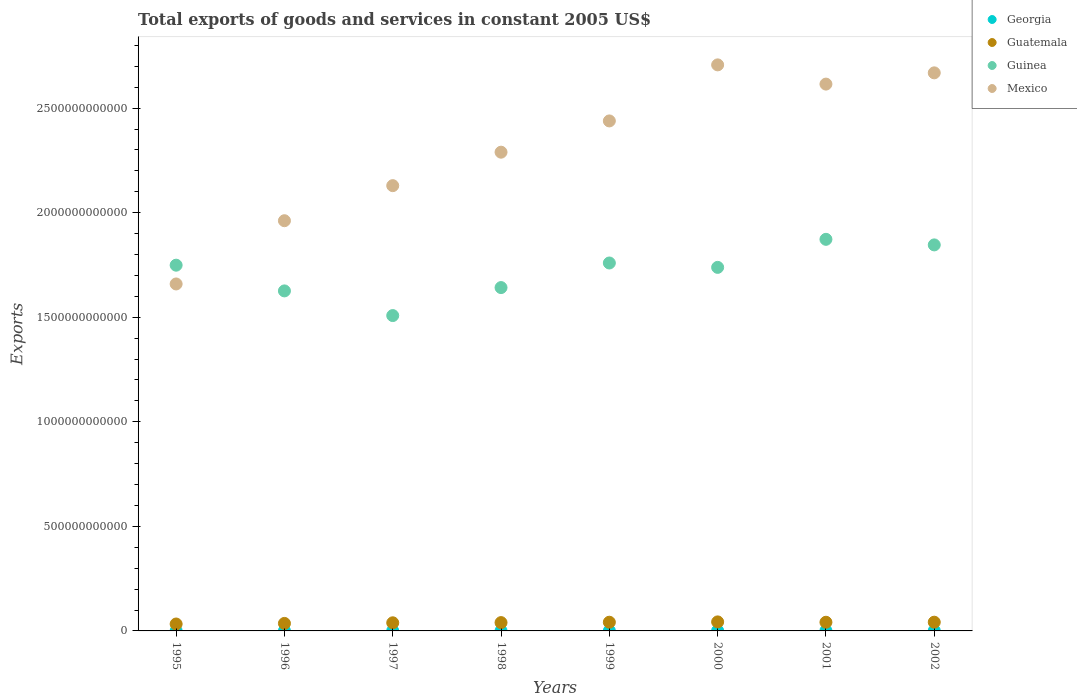How many different coloured dotlines are there?
Provide a short and direct response. 4. What is the total exports of goods and services in Georgia in 1999?
Provide a succinct answer. 8.64e+08. Across all years, what is the maximum total exports of goods and services in Guatemala?
Provide a short and direct response. 4.32e+1. Across all years, what is the minimum total exports of goods and services in Mexico?
Your response must be concise. 1.66e+12. In which year was the total exports of goods and services in Mexico minimum?
Your answer should be very brief. 1995. What is the total total exports of goods and services in Mexico in the graph?
Give a very brief answer. 1.85e+13. What is the difference between the total exports of goods and services in Guatemala in 1995 and that in 2001?
Give a very brief answer. -8.41e+09. What is the difference between the total exports of goods and services in Mexico in 1997 and the total exports of goods and services in Georgia in 1996?
Your answer should be compact. 2.13e+12. What is the average total exports of goods and services in Georgia per year?
Give a very brief answer. 8.73e+08. In the year 2002, what is the difference between the total exports of goods and services in Guatemala and total exports of goods and services in Mexico?
Your response must be concise. -2.63e+12. What is the ratio of the total exports of goods and services in Georgia in 1997 to that in 2000?
Make the answer very short. 0.63. Is the total exports of goods and services in Guatemala in 1997 less than that in 1999?
Your answer should be very brief. Yes. Is the difference between the total exports of goods and services in Guatemala in 1997 and 2001 greater than the difference between the total exports of goods and services in Mexico in 1997 and 2001?
Offer a very short reply. Yes. What is the difference between the highest and the second highest total exports of goods and services in Georgia?
Your answer should be very brief. 3.08e+08. What is the difference between the highest and the lowest total exports of goods and services in Mexico?
Ensure brevity in your answer.  1.05e+12. Is the sum of the total exports of goods and services in Guinea in 1996 and 2000 greater than the maximum total exports of goods and services in Georgia across all years?
Keep it short and to the point. Yes. Is it the case that in every year, the sum of the total exports of goods and services in Guatemala and total exports of goods and services in Georgia  is greater than the sum of total exports of goods and services in Mexico and total exports of goods and services in Guinea?
Keep it short and to the point. No. Is it the case that in every year, the sum of the total exports of goods and services in Guinea and total exports of goods and services in Guatemala  is greater than the total exports of goods and services in Georgia?
Ensure brevity in your answer.  Yes. Does the total exports of goods and services in Georgia monotonically increase over the years?
Provide a succinct answer. Yes. Is the total exports of goods and services in Guinea strictly greater than the total exports of goods and services in Mexico over the years?
Offer a very short reply. No. How many years are there in the graph?
Provide a succinct answer. 8. What is the difference between two consecutive major ticks on the Y-axis?
Ensure brevity in your answer.  5.00e+11. Does the graph contain grids?
Provide a short and direct response. No. How many legend labels are there?
Keep it short and to the point. 4. What is the title of the graph?
Make the answer very short. Total exports of goods and services in constant 2005 US$. What is the label or title of the Y-axis?
Your answer should be very brief. Exports. What is the Exports in Georgia in 1995?
Your answer should be very brief. 4.73e+08. What is the Exports in Guatemala in 1995?
Your answer should be very brief. 3.31e+1. What is the Exports of Guinea in 1995?
Keep it short and to the point. 1.75e+12. What is the Exports of Mexico in 1995?
Make the answer very short. 1.66e+12. What is the Exports of Georgia in 1996?
Offer a terse response. 5.16e+08. What is the Exports of Guatemala in 1996?
Give a very brief answer. 3.59e+1. What is the Exports in Guinea in 1996?
Make the answer very short. 1.63e+12. What is the Exports of Mexico in 1996?
Your response must be concise. 1.96e+12. What is the Exports of Georgia in 1997?
Ensure brevity in your answer.  6.67e+08. What is the Exports of Guatemala in 1997?
Keep it short and to the point. 3.88e+1. What is the Exports of Guinea in 1997?
Offer a terse response. 1.51e+12. What is the Exports of Mexico in 1997?
Offer a very short reply. 2.13e+12. What is the Exports of Georgia in 1998?
Your answer should be compact. 7.26e+08. What is the Exports of Guatemala in 1998?
Make the answer very short. 3.98e+1. What is the Exports of Guinea in 1998?
Your answer should be compact. 1.64e+12. What is the Exports of Mexico in 1998?
Make the answer very short. 2.29e+12. What is the Exports of Georgia in 1999?
Ensure brevity in your answer.  8.64e+08. What is the Exports of Guatemala in 1999?
Offer a terse response. 4.16e+1. What is the Exports in Guinea in 1999?
Give a very brief answer. 1.76e+12. What is the Exports in Mexico in 1999?
Keep it short and to the point. 2.44e+12. What is the Exports in Georgia in 2000?
Make the answer very short. 1.06e+09. What is the Exports of Guatemala in 2000?
Make the answer very short. 4.32e+1. What is the Exports of Guinea in 2000?
Offer a very short reply. 1.74e+12. What is the Exports of Mexico in 2000?
Your answer should be compact. 2.71e+12. What is the Exports of Georgia in 2001?
Make the answer very short. 1.18e+09. What is the Exports in Guatemala in 2001?
Offer a very short reply. 4.15e+1. What is the Exports of Guinea in 2001?
Provide a short and direct response. 1.87e+12. What is the Exports of Mexico in 2001?
Keep it short and to the point. 2.61e+12. What is the Exports of Georgia in 2002?
Make the answer very short. 1.49e+09. What is the Exports in Guatemala in 2002?
Provide a succinct answer. 4.18e+1. What is the Exports of Guinea in 2002?
Offer a terse response. 1.85e+12. What is the Exports in Mexico in 2002?
Give a very brief answer. 2.67e+12. Across all years, what is the maximum Exports in Georgia?
Offer a terse response. 1.49e+09. Across all years, what is the maximum Exports in Guatemala?
Give a very brief answer. 4.32e+1. Across all years, what is the maximum Exports of Guinea?
Ensure brevity in your answer.  1.87e+12. Across all years, what is the maximum Exports in Mexico?
Ensure brevity in your answer.  2.71e+12. Across all years, what is the minimum Exports in Georgia?
Offer a very short reply. 4.73e+08. Across all years, what is the minimum Exports in Guatemala?
Give a very brief answer. 3.31e+1. Across all years, what is the minimum Exports in Guinea?
Make the answer very short. 1.51e+12. Across all years, what is the minimum Exports of Mexico?
Provide a succinct answer. 1.66e+12. What is the total Exports of Georgia in the graph?
Your answer should be compact. 6.98e+09. What is the total Exports of Guatemala in the graph?
Ensure brevity in your answer.  3.16e+11. What is the total Exports of Guinea in the graph?
Keep it short and to the point. 1.37e+13. What is the total Exports in Mexico in the graph?
Provide a succinct answer. 1.85e+13. What is the difference between the Exports in Georgia in 1995 and that in 1996?
Offer a very short reply. -4.24e+07. What is the difference between the Exports in Guatemala in 1995 and that in 1996?
Your response must be concise. -2.87e+09. What is the difference between the Exports in Guinea in 1995 and that in 1996?
Your answer should be very brief. 1.23e+11. What is the difference between the Exports of Mexico in 1995 and that in 1996?
Offer a very short reply. -3.02e+11. What is the difference between the Exports in Georgia in 1995 and that in 1997?
Your answer should be very brief. -1.94e+08. What is the difference between the Exports in Guatemala in 1995 and that in 1997?
Offer a very short reply. -5.78e+09. What is the difference between the Exports of Guinea in 1995 and that in 1997?
Give a very brief answer. 2.41e+11. What is the difference between the Exports in Mexico in 1995 and that in 1997?
Give a very brief answer. -4.70e+11. What is the difference between the Exports of Georgia in 1995 and that in 1998?
Give a very brief answer. -2.52e+08. What is the difference between the Exports of Guatemala in 1995 and that in 1998?
Provide a succinct answer. -6.71e+09. What is the difference between the Exports of Guinea in 1995 and that in 1998?
Keep it short and to the point. 1.07e+11. What is the difference between the Exports of Mexico in 1995 and that in 1998?
Provide a short and direct response. -6.30e+11. What is the difference between the Exports in Georgia in 1995 and that in 1999?
Provide a succinct answer. -3.91e+08. What is the difference between the Exports of Guatemala in 1995 and that in 1999?
Your answer should be very brief. -8.54e+09. What is the difference between the Exports in Guinea in 1995 and that in 1999?
Offer a terse response. -1.05e+1. What is the difference between the Exports in Mexico in 1995 and that in 1999?
Your response must be concise. -7.80e+11. What is the difference between the Exports in Georgia in 1995 and that in 2000?
Provide a succinct answer. -5.89e+08. What is the difference between the Exports of Guatemala in 1995 and that in 2000?
Your response must be concise. -1.01e+1. What is the difference between the Exports in Guinea in 1995 and that in 2000?
Ensure brevity in your answer.  1.05e+1. What is the difference between the Exports in Mexico in 1995 and that in 2000?
Make the answer very short. -1.05e+12. What is the difference between the Exports in Georgia in 1995 and that in 2001?
Provide a short and direct response. -7.11e+08. What is the difference between the Exports in Guatemala in 1995 and that in 2001?
Give a very brief answer. -8.41e+09. What is the difference between the Exports of Guinea in 1995 and that in 2001?
Your response must be concise. -1.24e+11. What is the difference between the Exports in Mexico in 1995 and that in 2001?
Your answer should be compact. -9.56e+11. What is the difference between the Exports of Georgia in 1995 and that in 2002?
Your answer should be very brief. -1.02e+09. What is the difference between the Exports of Guatemala in 1995 and that in 2002?
Your response must be concise. -8.70e+09. What is the difference between the Exports in Guinea in 1995 and that in 2002?
Provide a short and direct response. -9.69e+1. What is the difference between the Exports of Mexico in 1995 and that in 2002?
Provide a succinct answer. -1.01e+12. What is the difference between the Exports in Georgia in 1996 and that in 1997?
Make the answer very short. -1.52e+08. What is the difference between the Exports in Guatemala in 1996 and that in 1997?
Provide a succinct answer. -2.91e+09. What is the difference between the Exports of Guinea in 1996 and that in 1997?
Make the answer very short. 1.18e+11. What is the difference between the Exports of Mexico in 1996 and that in 1997?
Your answer should be compact. -1.68e+11. What is the difference between the Exports in Georgia in 1996 and that in 1998?
Your answer should be compact. -2.10e+08. What is the difference between the Exports in Guatemala in 1996 and that in 1998?
Offer a terse response. -3.84e+09. What is the difference between the Exports in Guinea in 1996 and that in 1998?
Your response must be concise. -1.59e+1. What is the difference between the Exports in Mexico in 1996 and that in 1998?
Your answer should be very brief. -3.28e+11. What is the difference between the Exports of Georgia in 1996 and that in 1999?
Your answer should be compact. -3.49e+08. What is the difference between the Exports of Guatemala in 1996 and that in 1999?
Your answer should be compact. -5.67e+09. What is the difference between the Exports in Guinea in 1996 and that in 1999?
Your answer should be compact. -1.33e+11. What is the difference between the Exports of Mexico in 1996 and that in 1999?
Ensure brevity in your answer.  -4.77e+11. What is the difference between the Exports of Georgia in 1996 and that in 2000?
Your answer should be very brief. -5.46e+08. What is the difference between the Exports of Guatemala in 1996 and that in 2000?
Offer a very short reply. -7.26e+09. What is the difference between the Exports of Guinea in 1996 and that in 2000?
Offer a terse response. -1.13e+11. What is the difference between the Exports of Mexico in 1996 and that in 2000?
Offer a very short reply. -7.45e+11. What is the difference between the Exports in Georgia in 1996 and that in 2001?
Offer a very short reply. -6.68e+08. What is the difference between the Exports of Guatemala in 1996 and that in 2001?
Ensure brevity in your answer.  -5.54e+09. What is the difference between the Exports in Guinea in 1996 and that in 2001?
Provide a short and direct response. -2.47e+11. What is the difference between the Exports in Mexico in 1996 and that in 2001?
Keep it short and to the point. -6.53e+11. What is the difference between the Exports of Georgia in 1996 and that in 2002?
Keep it short and to the point. -9.77e+08. What is the difference between the Exports of Guatemala in 1996 and that in 2002?
Provide a succinct answer. -5.83e+09. What is the difference between the Exports of Guinea in 1996 and that in 2002?
Give a very brief answer. -2.20e+11. What is the difference between the Exports in Mexico in 1996 and that in 2002?
Give a very brief answer. -7.07e+11. What is the difference between the Exports in Georgia in 1997 and that in 1998?
Offer a very short reply. -5.81e+07. What is the difference between the Exports in Guatemala in 1997 and that in 1998?
Your answer should be very brief. -9.30e+08. What is the difference between the Exports of Guinea in 1997 and that in 1998?
Provide a succinct answer. -1.34e+11. What is the difference between the Exports in Mexico in 1997 and that in 1998?
Provide a succinct answer. -1.60e+11. What is the difference between the Exports of Georgia in 1997 and that in 1999?
Provide a succinct answer. -1.97e+08. What is the difference between the Exports of Guatemala in 1997 and that in 1999?
Provide a short and direct response. -2.76e+09. What is the difference between the Exports of Guinea in 1997 and that in 1999?
Ensure brevity in your answer.  -2.51e+11. What is the difference between the Exports of Mexico in 1997 and that in 1999?
Your answer should be very brief. -3.09e+11. What is the difference between the Exports in Georgia in 1997 and that in 2000?
Offer a very short reply. -3.94e+08. What is the difference between the Exports of Guatemala in 1997 and that in 2000?
Keep it short and to the point. -4.35e+09. What is the difference between the Exports in Guinea in 1997 and that in 2000?
Provide a short and direct response. -2.31e+11. What is the difference between the Exports in Mexico in 1997 and that in 2000?
Provide a succinct answer. -5.78e+11. What is the difference between the Exports in Georgia in 1997 and that in 2001?
Give a very brief answer. -5.17e+08. What is the difference between the Exports in Guatemala in 1997 and that in 2001?
Your response must be concise. -2.63e+09. What is the difference between the Exports of Guinea in 1997 and that in 2001?
Make the answer very short. -3.65e+11. What is the difference between the Exports in Mexico in 1997 and that in 2001?
Keep it short and to the point. -4.86e+11. What is the difference between the Exports of Georgia in 1997 and that in 2002?
Offer a very short reply. -8.25e+08. What is the difference between the Exports in Guatemala in 1997 and that in 2002?
Ensure brevity in your answer.  -2.92e+09. What is the difference between the Exports of Guinea in 1997 and that in 2002?
Offer a very short reply. -3.38e+11. What is the difference between the Exports of Mexico in 1997 and that in 2002?
Make the answer very short. -5.39e+11. What is the difference between the Exports in Georgia in 1998 and that in 1999?
Provide a succinct answer. -1.39e+08. What is the difference between the Exports of Guatemala in 1998 and that in 1999?
Keep it short and to the point. -1.83e+09. What is the difference between the Exports in Guinea in 1998 and that in 1999?
Provide a short and direct response. -1.18e+11. What is the difference between the Exports in Mexico in 1998 and that in 1999?
Provide a short and direct response. -1.49e+11. What is the difference between the Exports in Georgia in 1998 and that in 2000?
Offer a terse response. -3.36e+08. What is the difference between the Exports of Guatemala in 1998 and that in 2000?
Provide a short and direct response. -3.42e+09. What is the difference between the Exports in Guinea in 1998 and that in 2000?
Ensure brevity in your answer.  -9.66e+1. What is the difference between the Exports in Mexico in 1998 and that in 2000?
Offer a very short reply. -4.18e+11. What is the difference between the Exports of Georgia in 1998 and that in 2001?
Offer a very short reply. -4.58e+08. What is the difference between the Exports of Guatemala in 1998 and that in 2001?
Give a very brief answer. -1.70e+09. What is the difference between the Exports in Guinea in 1998 and that in 2001?
Keep it short and to the point. -2.31e+11. What is the difference between the Exports in Mexico in 1998 and that in 2001?
Provide a succinct answer. -3.26e+11. What is the difference between the Exports of Georgia in 1998 and that in 2002?
Your answer should be very brief. -7.67e+08. What is the difference between the Exports of Guatemala in 1998 and that in 2002?
Your answer should be very brief. -1.99e+09. What is the difference between the Exports of Guinea in 1998 and that in 2002?
Provide a short and direct response. -2.04e+11. What is the difference between the Exports in Mexico in 1998 and that in 2002?
Provide a short and direct response. -3.79e+11. What is the difference between the Exports of Georgia in 1999 and that in 2000?
Offer a terse response. -1.98e+08. What is the difference between the Exports in Guatemala in 1999 and that in 2000?
Give a very brief answer. -1.59e+09. What is the difference between the Exports in Guinea in 1999 and that in 2000?
Make the answer very short. 2.10e+1. What is the difference between the Exports in Mexico in 1999 and that in 2000?
Provide a succinct answer. -2.68e+11. What is the difference between the Exports of Georgia in 1999 and that in 2001?
Ensure brevity in your answer.  -3.20e+08. What is the difference between the Exports in Guatemala in 1999 and that in 2001?
Ensure brevity in your answer.  1.35e+08. What is the difference between the Exports in Guinea in 1999 and that in 2001?
Offer a very short reply. -1.13e+11. What is the difference between the Exports of Mexico in 1999 and that in 2001?
Make the answer very short. -1.76e+11. What is the difference between the Exports of Georgia in 1999 and that in 2002?
Keep it short and to the point. -6.28e+08. What is the difference between the Exports of Guatemala in 1999 and that in 2002?
Make the answer very short. -1.59e+08. What is the difference between the Exports of Guinea in 1999 and that in 2002?
Your answer should be very brief. -8.65e+1. What is the difference between the Exports in Mexico in 1999 and that in 2002?
Offer a terse response. -2.30e+11. What is the difference between the Exports of Georgia in 2000 and that in 2001?
Keep it short and to the point. -1.22e+08. What is the difference between the Exports of Guatemala in 2000 and that in 2001?
Make the answer very short. 1.72e+09. What is the difference between the Exports in Guinea in 2000 and that in 2001?
Your answer should be very brief. -1.34e+11. What is the difference between the Exports of Mexico in 2000 and that in 2001?
Offer a terse response. 9.19e+1. What is the difference between the Exports in Georgia in 2000 and that in 2002?
Provide a succinct answer. -4.30e+08. What is the difference between the Exports of Guatemala in 2000 and that in 2002?
Give a very brief answer. 1.43e+09. What is the difference between the Exports in Guinea in 2000 and that in 2002?
Provide a succinct answer. -1.07e+11. What is the difference between the Exports of Mexico in 2000 and that in 2002?
Your answer should be compact. 3.81e+1. What is the difference between the Exports of Georgia in 2001 and that in 2002?
Ensure brevity in your answer.  -3.08e+08. What is the difference between the Exports in Guatemala in 2001 and that in 2002?
Your answer should be compact. -2.94e+08. What is the difference between the Exports of Guinea in 2001 and that in 2002?
Provide a succinct answer. 2.67e+1. What is the difference between the Exports of Mexico in 2001 and that in 2002?
Provide a short and direct response. -5.38e+1. What is the difference between the Exports of Georgia in 1995 and the Exports of Guatemala in 1996?
Give a very brief answer. -3.54e+1. What is the difference between the Exports of Georgia in 1995 and the Exports of Guinea in 1996?
Keep it short and to the point. -1.63e+12. What is the difference between the Exports in Georgia in 1995 and the Exports in Mexico in 1996?
Provide a short and direct response. -1.96e+12. What is the difference between the Exports in Guatemala in 1995 and the Exports in Guinea in 1996?
Provide a succinct answer. -1.59e+12. What is the difference between the Exports in Guatemala in 1995 and the Exports in Mexico in 1996?
Provide a succinct answer. -1.93e+12. What is the difference between the Exports in Guinea in 1995 and the Exports in Mexico in 1996?
Your answer should be very brief. -2.13e+11. What is the difference between the Exports of Georgia in 1995 and the Exports of Guatemala in 1997?
Provide a short and direct response. -3.84e+1. What is the difference between the Exports in Georgia in 1995 and the Exports in Guinea in 1997?
Offer a very short reply. -1.51e+12. What is the difference between the Exports of Georgia in 1995 and the Exports of Mexico in 1997?
Your answer should be compact. -2.13e+12. What is the difference between the Exports in Guatemala in 1995 and the Exports in Guinea in 1997?
Make the answer very short. -1.47e+12. What is the difference between the Exports in Guatemala in 1995 and the Exports in Mexico in 1997?
Offer a very short reply. -2.10e+12. What is the difference between the Exports in Guinea in 1995 and the Exports in Mexico in 1997?
Your response must be concise. -3.80e+11. What is the difference between the Exports of Georgia in 1995 and the Exports of Guatemala in 1998?
Your response must be concise. -3.93e+1. What is the difference between the Exports in Georgia in 1995 and the Exports in Guinea in 1998?
Your answer should be compact. -1.64e+12. What is the difference between the Exports in Georgia in 1995 and the Exports in Mexico in 1998?
Your answer should be compact. -2.29e+12. What is the difference between the Exports in Guatemala in 1995 and the Exports in Guinea in 1998?
Your answer should be very brief. -1.61e+12. What is the difference between the Exports of Guatemala in 1995 and the Exports of Mexico in 1998?
Provide a succinct answer. -2.26e+12. What is the difference between the Exports in Guinea in 1995 and the Exports in Mexico in 1998?
Provide a short and direct response. -5.40e+11. What is the difference between the Exports of Georgia in 1995 and the Exports of Guatemala in 1999?
Offer a very short reply. -4.11e+1. What is the difference between the Exports in Georgia in 1995 and the Exports in Guinea in 1999?
Your answer should be very brief. -1.76e+12. What is the difference between the Exports in Georgia in 1995 and the Exports in Mexico in 1999?
Your answer should be compact. -2.44e+12. What is the difference between the Exports of Guatemala in 1995 and the Exports of Guinea in 1999?
Make the answer very short. -1.73e+12. What is the difference between the Exports in Guatemala in 1995 and the Exports in Mexico in 1999?
Give a very brief answer. -2.41e+12. What is the difference between the Exports in Guinea in 1995 and the Exports in Mexico in 1999?
Provide a succinct answer. -6.90e+11. What is the difference between the Exports of Georgia in 1995 and the Exports of Guatemala in 2000?
Your response must be concise. -4.27e+1. What is the difference between the Exports of Georgia in 1995 and the Exports of Guinea in 2000?
Provide a short and direct response. -1.74e+12. What is the difference between the Exports in Georgia in 1995 and the Exports in Mexico in 2000?
Offer a terse response. -2.71e+12. What is the difference between the Exports of Guatemala in 1995 and the Exports of Guinea in 2000?
Provide a short and direct response. -1.71e+12. What is the difference between the Exports in Guatemala in 1995 and the Exports in Mexico in 2000?
Ensure brevity in your answer.  -2.67e+12. What is the difference between the Exports of Guinea in 1995 and the Exports of Mexico in 2000?
Provide a short and direct response. -9.58e+11. What is the difference between the Exports of Georgia in 1995 and the Exports of Guatemala in 2001?
Your answer should be very brief. -4.10e+1. What is the difference between the Exports in Georgia in 1995 and the Exports in Guinea in 2001?
Ensure brevity in your answer.  -1.87e+12. What is the difference between the Exports of Georgia in 1995 and the Exports of Mexico in 2001?
Offer a terse response. -2.61e+12. What is the difference between the Exports in Guatemala in 1995 and the Exports in Guinea in 2001?
Your response must be concise. -1.84e+12. What is the difference between the Exports in Guatemala in 1995 and the Exports in Mexico in 2001?
Ensure brevity in your answer.  -2.58e+12. What is the difference between the Exports of Guinea in 1995 and the Exports of Mexico in 2001?
Your response must be concise. -8.66e+11. What is the difference between the Exports of Georgia in 1995 and the Exports of Guatemala in 2002?
Provide a succinct answer. -4.13e+1. What is the difference between the Exports of Georgia in 1995 and the Exports of Guinea in 2002?
Ensure brevity in your answer.  -1.85e+12. What is the difference between the Exports in Georgia in 1995 and the Exports in Mexico in 2002?
Make the answer very short. -2.67e+12. What is the difference between the Exports of Guatemala in 1995 and the Exports of Guinea in 2002?
Provide a succinct answer. -1.81e+12. What is the difference between the Exports of Guatemala in 1995 and the Exports of Mexico in 2002?
Your answer should be compact. -2.64e+12. What is the difference between the Exports of Guinea in 1995 and the Exports of Mexico in 2002?
Ensure brevity in your answer.  -9.20e+11. What is the difference between the Exports in Georgia in 1996 and the Exports in Guatemala in 1997?
Keep it short and to the point. -3.83e+1. What is the difference between the Exports of Georgia in 1996 and the Exports of Guinea in 1997?
Give a very brief answer. -1.51e+12. What is the difference between the Exports of Georgia in 1996 and the Exports of Mexico in 1997?
Provide a succinct answer. -2.13e+12. What is the difference between the Exports of Guatemala in 1996 and the Exports of Guinea in 1997?
Offer a terse response. -1.47e+12. What is the difference between the Exports of Guatemala in 1996 and the Exports of Mexico in 1997?
Keep it short and to the point. -2.09e+12. What is the difference between the Exports of Guinea in 1996 and the Exports of Mexico in 1997?
Ensure brevity in your answer.  -5.03e+11. What is the difference between the Exports in Georgia in 1996 and the Exports in Guatemala in 1998?
Your answer should be compact. -3.92e+1. What is the difference between the Exports of Georgia in 1996 and the Exports of Guinea in 1998?
Make the answer very short. -1.64e+12. What is the difference between the Exports in Georgia in 1996 and the Exports in Mexico in 1998?
Offer a terse response. -2.29e+12. What is the difference between the Exports in Guatemala in 1996 and the Exports in Guinea in 1998?
Make the answer very short. -1.61e+12. What is the difference between the Exports of Guatemala in 1996 and the Exports of Mexico in 1998?
Provide a short and direct response. -2.25e+12. What is the difference between the Exports of Guinea in 1996 and the Exports of Mexico in 1998?
Offer a terse response. -6.63e+11. What is the difference between the Exports of Georgia in 1996 and the Exports of Guatemala in 1999?
Offer a terse response. -4.11e+1. What is the difference between the Exports of Georgia in 1996 and the Exports of Guinea in 1999?
Offer a very short reply. -1.76e+12. What is the difference between the Exports of Georgia in 1996 and the Exports of Mexico in 1999?
Offer a terse response. -2.44e+12. What is the difference between the Exports of Guatemala in 1996 and the Exports of Guinea in 1999?
Ensure brevity in your answer.  -1.72e+12. What is the difference between the Exports of Guatemala in 1996 and the Exports of Mexico in 1999?
Your answer should be compact. -2.40e+12. What is the difference between the Exports in Guinea in 1996 and the Exports in Mexico in 1999?
Provide a succinct answer. -8.13e+11. What is the difference between the Exports in Georgia in 1996 and the Exports in Guatemala in 2000?
Your response must be concise. -4.27e+1. What is the difference between the Exports in Georgia in 1996 and the Exports in Guinea in 2000?
Provide a short and direct response. -1.74e+12. What is the difference between the Exports in Georgia in 1996 and the Exports in Mexico in 2000?
Offer a very short reply. -2.71e+12. What is the difference between the Exports of Guatemala in 1996 and the Exports of Guinea in 2000?
Your answer should be very brief. -1.70e+12. What is the difference between the Exports in Guatemala in 1996 and the Exports in Mexico in 2000?
Provide a succinct answer. -2.67e+12. What is the difference between the Exports of Guinea in 1996 and the Exports of Mexico in 2000?
Provide a short and direct response. -1.08e+12. What is the difference between the Exports of Georgia in 1996 and the Exports of Guatemala in 2001?
Your response must be concise. -4.09e+1. What is the difference between the Exports in Georgia in 1996 and the Exports in Guinea in 2001?
Give a very brief answer. -1.87e+12. What is the difference between the Exports of Georgia in 1996 and the Exports of Mexico in 2001?
Make the answer very short. -2.61e+12. What is the difference between the Exports in Guatemala in 1996 and the Exports in Guinea in 2001?
Offer a terse response. -1.84e+12. What is the difference between the Exports of Guatemala in 1996 and the Exports of Mexico in 2001?
Your response must be concise. -2.58e+12. What is the difference between the Exports in Guinea in 1996 and the Exports in Mexico in 2001?
Keep it short and to the point. -9.89e+11. What is the difference between the Exports of Georgia in 1996 and the Exports of Guatemala in 2002?
Offer a very short reply. -4.12e+1. What is the difference between the Exports of Georgia in 1996 and the Exports of Guinea in 2002?
Keep it short and to the point. -1.85e+12. What is the difference between the Exports of Georgia in 1996 and the Exports of Mexico in 2002?
Your answer should be compact. -2.67e+12. What is the difference between the Exports in Guatemala in 1996 and the Exports in Guinea in 2002?
Offer a terse response. -1.81e+12. What is the difference between the Exports of Guatemala in 1996 and the Exports of Mexico in 2002?
Keep it short and to the point. -2.63e+12. What is the difference between the Exports of Guinea in 1996 and the Exports of Mexico in 2002?
Make the answer very short. -1.04e+12. What is the difference between the Exports of Georgia in 1997 and the Exports of Guatemala in 1998?
Your answer should be very brief. -3.91e+1. What is the difference between the Exports of Georgia in 1997 and the Exports of Guinea in 1998?
Your answer should be very brief. -1.64e+12. What is the difference between the Exports in Georgia in 1997 and the Exports in Mexico in 1998?
Give a very brief answer. -2.29e+12. What is the difference between the Exports in Guatemala in 1997 and the Exports in Guinea in 1998?
Provide a short and direct response. -1.60e+12. What is the difference between the Exports of Guatemala in 1997 and the Exports of Mexico in 1998?
Ensure brevity in your answer.  -2.25e+12. What is the difference between the Exports in Guinea in 1997 and the Exports in Mexico in 1998?
Provide a short and direct response. -7.81e+11. What is the difference between the Exports of Georgia in 1997 and the Exports of Guatemala in 1999?
Your response must be concise. -4.09e+1. What is the difference between the Exports in Georgia in 1997 and the Exports in Guinea in 1999?
Offer a very short reply. -1.76e+12. What is the difference between the Exports in Georgia in 1997 and the Exports in Mexico in 1999?
Keep it short and to the point. -2.44e+12. What is the difference between the Exports of Guatemala in 1997 and the Exports of Guinea in 1999?
Give a very brief answer. -1.72e+12. What is the difference between the Exports in Guatemala in 1997 and the Exports in Mexico in 1999?
Offer a very short reply. -2.40e+12. What is the difference between the Exports in Guinea in 1997 and the Exports in Mexico in 1999?
Offer a terse response. -9.31e+11. What is the difference between the Exports in Georgia in 1997 and the Exports in Guatemala in 2000?
Your response must be concise. -4.25e+1. What is the difference between the Exports in Georgia in 1997 and the Exports in Guinea in 2000?
Provide a succinct answer. -1.74e+12. What is the difference between the Exports in Georgia in 1997 and the Exports in Mexico in 2000?
Give a very brief answer. -2.71e+12. What is the difference between the Exports in Guatemala in 1997 and the Exports in Guinea in 2000?
Your answer should be very brief. -1.70e+12. What is the difference between the Exports of Guatemala in 1997 and the Exports of Mexico in 2000?
Provide a short and direct response. -2.67e+12. What is the difference between the Exports in Guinea in 1997 and the Exports in Mexico in 2000?
Make the answer very short. -1.20e+12. What is the difference between the Exports of Georgia in 1997 and the Exports of Guatemala in 2001?
Ensure brevity in your answer.  -4.08e+1. What is the difference between the Exports in Georgia in 1997 and the Exports in Guinea in 2001?
Make the answer very short. -1.87e+12. What is the difference between the Exports in Georgia in 1997 and the Exports in Mexico in 2001?
Ensure brevity in your answer.  -2.61e+12. What is the difference between the Exports in Guatemala in 1997 and the Exports in Guinea in 2001?
Your response must be concise. -1.83e+12. What is the difference between the Exports in Guatemala in 1997 and the Exports in Mexico in 2001?
Your answer should be very brief. -2.58e+12. What is the difference between the Exports of Guinea in 1997 and the Exports of Mexico in 2001?
Provide a short and direct response. -1.11e+12. What is the difference between the Exports in Georgia in 1997 and the Exports in Guatemala in 2002?
Ensure brevity in your answer.  -4.11e+1. What is the difference between the Exports of Georgia in 1997 and the Exports of Guinea in 2002?
Offer a very short reply. -1.85e+12. What is the difference between the Exports in Georgia in 1997 and the Exports in Mexico in 2002?
Provide a short and direct response. -2.67e+12. What is the difference between the Exports of Guatemala in 1997 and the Exports of Guinea in 2002?
Keep it short and to the point. -1.81e+12. What is the difference between the Exports of Guatemala in 1997 and the Exports of Mexico in 2002?
Your answer should be compact. -2.63e+12. What is the difference between the Exports of Guinea in 1997 and the Exports of Mexico in 2002?
Provide a short and direct response. -1.16e+12. What is the difference between the Exports of Georgia in 1998 and the Exports of Guatemala in 1999?
Ensure brevity in your answer.  -4.09e+1. What is the difference between the Exports of Georgia in 1998 and the Exports of Guinea in 1999?
Your response must be concise. -1.76e+12. What is the difference between the Exports in Georgia in 1998 and the Exports in Mexico in 1999?
Provide a succinct answer. -2.44e+12. What is the difference between the Exports of Guatemala in 1998 and the Exports of Guinea in 1999?
Your answer should be compact. -1.72e+12. What is the difference between the Exports of Guatemala in 1998 and the Exports of Mexico in 1999?
Offer a terse response. -2.40e+12. What is the difference between the Exports in Guinea in 1998 and the Exports in Mexico in 1999?
Give a very brief answer. -7.97e+11. What is the difference between the Exports of Georgia in 1998 and the Exports of Guatemala in 2000?
Provide a short and direct response. -4.25e+1. What is the difference between the Exports of Georgia in 1998 and the Exports of Guinea in 2000?
Your answer should be compact. -1.74e+12. What is the difference between the Exports in Georgia in 1998 and the Exports in Mexico in 2000?
Your answer should be compact. -2.71e+12. What is the difference between the Exports in Guatemala in 1998 and the Exports in Guinea in 2000?
Your response must be concise. -1.70e+12. What is the difference between the Exports of Guatemala in 1998 and the Exports of Mexico in 2000?
Provide a succinct answer. -2.67e+12. What is the difference between the Exports of Guinea in 1998 and the Exports of Mexico in 2000?
Provide a succinct answer. -1.06e+12. What is the difference between the Exports in Georgia in 1998 and the Exports in Guatemala in 2001?
Your response must be concise. -4.07e+1. What is the difference between the Exports of Georgia in 1998 and the Exports of Guinea in 2001?
Offer a very short reply. -1.87e+12. What is the difference between the Exports in Georgia in 1998 and the Exports in Mexico in 2001?
Your response must be concise. -2.61e+12. What is the difference between the Exports in Guatemala in 1998 and the Exports in Guinea in 2001?
Offer a very short reply. -1.83e+12. What is the difference between the Exports in Guatemala in 1998 and the Exports in Mexico in 2001?
Your answer should be very brief. -2.58e+12. What is the difference between the Exports in Guinea in 1998 and the Exports in Mexico in 2001?
Keep it short and to the point. -9.73e+11. What is the difference between the Exports of Georgia in 1998 and the Exports of Guatemala in 2002?
Make the answer very short. -4.10e+1. What is the difference between the Exports of Georgia in 1998 and the Exports of Guinea in 2002?
Ensure brevity in your answer.  -1.85e+12. What is the difference between the Exports of Georgia in 1998 and the Exports of Mexico in 2002?
Give a very brief answer. -2.67e+12. What is the difference between the Exports in Guatemala in 1998 and the Exports in Guinea in 2002?
Make the answer very short. -1.81e+12. What is the difference between the Exports of Guatemala in 1998 and the Exports of Mexico in 2002?
Offer a terse response. -2.63e+12. What is the difference between the Exports in Guinea in 1998 and the Exports in Mexico in 2002?
Your response must be concise. -1.03e+12. What is the difference between the Exports of Georgia in 1999 and the Exports of Guatemala in 2000?
Keep it short and to the point. -4.23e+1. What is the difference between the Exports in Georgia in 1999 and the Exports in Guinea in 2000?
Your response must be concise. -1.74e+12. What is the difference between the Exports of Georgia in 1999 and the Exports of Mexico in 2000?
Your answer should be compact. -2.71e+12. What is the difference between the Exports in Guatemala in 1999 and the Exports in Guinea in 2000?
Make the answer very short. -1.70e+12. What is the difference between the Exports in Guatemala in 1999 and the Exports in Mexico in 2000?
Ensure brevity in your answer.  -2.67e+12. What is the difference between the Exports in Guinea in 1999 and the Exports in Mexico in 2000?
Your response must be concise. -9.47e+11. What is the difference between the Exports in Georgia in 1999 and the Exports in Guatemala in 2001?
Keep it short and to the point. -4.06e+1. What is the difference between the Exports in Georgia in 1999 and the Exports in Guinea in 2001?
Make the answer very short. -1.87e+12. What is the difference between the Exports in Georgia in 1999 and the Exports in Mexico in 2001?
Ensure brevity in your answer.  -2.61e+12. What is the difference between the Exports of Guatemala in 1999 and the Exports of Guinea in 2001?
Offer a very short reply. -1.83e+12. What is the difference between the Exports of Guatemala in 1999 and the Exports of Mexico in 2001?
Ensure brevity in your answer.  -2.57e+12. What is the difference between the Exports of Guinea in 1999 and the Exports of Mexico in 2001?
Your answer should be very brief. -8.55e+11. What is the difference between the Exports of Georgia in 1999 and the Exports of Guatemala in 2002?
Your answer should be very brief. -4.09e+1. What is the difference between the Exports of Georgia in 1999 and the Exports of Guinea in 2002?
Offer a terse response. -1.85e+12. What is the difference between the Exports in Georgia in 1999 and the Exports in Mexico in 2002?
Provide a succinct answer. -2.67e+12. What is the difference between the Exports in Guatemala in 1999 and the Exports in Guinea in 2002?
Provide a short and direct response. -1.80e+12. What is the difference between the Exports in Guatemala in 1999 and the Exports in Mexico in 2002?
Offer a very short reply. -2.63e+12. What is the difference between the Exports in Guinea in 1999 and the Exports in Mexico in 2002?
Your answer should be very brief. -9.09e+11. What is the difference between the Exports of Georgia in 2000 and the Exports of Guatemala in 2001?
Keep it short and to the point. -4.04e+1. What is the difference between the Exports of Georgia in 2000 and the Exports of Guinea in 2001?
Your response must be concise. -1.87e+12. What is the difference between the Exports in Georgia in 2000 and the Exports in Mexico in 2001?
Provide a short and direct response. -2.61e+12. What is the difference between the Exports in Guatemala in 2000 and the Exports in Guinea in 2001?
Your response must be concise. -1.83e+12. What is the difference between the Exports in Guatemala in 2000 and the Exports in Mexico in 2001?
Give a very brief answer. -2.57e+12. What is the difference between the Exports of Guinea in 2000 and the Exports of Mexico in 2001?
Keep it short and to the point. -8.76e+11. What is the difference between the Exports of Georgia in 2000 and the Exports of Guatemala in 2002?
Your answer should be compact. -4.07e+1. What is the difference between the Exports of Georgia in 2000 and the Exports of Guinea in 2002?
Give a very brief answer. -1.84e+12. What is the difference between the Exports in Georgia in 2000 and the Exports in Mexico in 2002?
Your answer should be very brief. -2.67e+12. What is the difference between the Exports in Guatemala in 2000 and the Exports in Guinea in 2002?
Your answer should be very brief. -1.80e+12. What is the difference between the Exports in Guatemala in 2000 and the Exports in Mexico in 2002?
Ensure brevity in your answer.  -2.63e+12. What is the difference between the Exports in Guinea in 2000 and the Exports in Mexico in 2002?
Keep it short and to the point. -9.30e+11. What is the difference between the Exports of Georgia in 2001 and the Exports of Guatemala in 2002?
Make the answer very short. -4.06e+1. What is the difference between the Exports of Georgia in 2001 and the Exports of Guinea in 2002?
Provide a short and direct response. -1.84e+12. What is the difference between the Exports of Georgia in 2001 and the Exports of Mexico in 2002?
Provide a succinct answer. -2.67e+12. What is the difference between the Exports of Guatemala in 2001 and the Exports of Guinea in 2002?
Your answer should be compact. -1.80e+12. What is the difference between the Exports of Guatemala in 2001 and the Exports of Mexico in 2002?
Keep it short and to the point. -2.63e+12. What is the difference between the Exports of Guinea in 2001 and the Exports of Mexico in 2002?
Your response must be concise. -7.96e+11. What is the average Exports in Georgia per year?
Offer a very short reply. 8.73e+08. What is the average Exports of Guatemala per year?
Your answer should be very brief. 3.94e+1. What is the average Exports of Guinea per year?
Provide a succinct answer. 1.72e+12. What is the average Exports in Mexico per year?
Make the answer very short. 2.31e+12. In the year 1995, what is the difference between the Exports in Georgia and Exports in Guatemala?
Make the answer very short. -3.26e+1. In the year 1995, what is the difference between the Exports in Georgia and Exports in Guinea?
Your answer should be compact. -1.75e+12. In the year 1995, what is the difference between the Exports in Georgia and Exports in Mexico?
Keep it short and to the point. -1.66e+12. In the year 1995, what is the difference between the Exports of Guatemala and Exports of Guinea?
Your answer should be very brief. -1.72e+12. In the year 1995, what is the difference between the Exports of Guatemala and Exports of Mexico?
Offer a terse response. -1.63e+12. In the year 1995, what is the difference between the Exports in Guinea and Exports in Mexico?
Your answer should be very brief. 8.98e+1. In the year 1996, what is the difference between the Exports in Georgia and Exports in Guatemala?
Offer a terse response. -3.54e+1. In the year 1996, what is the difference between the Exports of Georgia and Exports of Guinea?
Give a very brief answer. -1.63e+12. In the year 1996, what is the difference between the Exports in Georgia and Exports in Mexico?
Ensure brevity in your answer.  -1.96e+12. In the year 1996, what is the difference between the Exports of Guatemala and Exports of Guinea?
Ensure brevity in your answer.  -1.59e+12. In the year 1996, what is the difference between the Exports of Guatemala and Exports of Mexico?
Offer a terse response. -1.93e+12. In the year 1996, what is the difference between the Exports of Guinea and Exports of Mexico?
Your answer should be compact. -3.36e+11. In the year 1997, what is the difference between the Exports in Georgia and Exports in Guatemala?
Your answer should be compact. -3.82e+1. In the year 1997, what is the difference between the Exports of Georgia and Exports of Guinea?
Make the answer very short. -1.51e+12. In the year 1997, what is the difference between the Exports of Georgia and Exports of Mexico?
Give a very brief answer. -2.13e+12. In the year 1997, what is the difference between the Exports of Guatemala and Exports of Guinea?
Give a very brief answer. -1.47e+12. In the year 1997, what is the difference between the Exports in Guatemala and Exports in Mexico?
Your answer should be very brief. -2.09e+12. In the year 1997, what is the difference between the Exports in Guinea and Exports in Mexico?
Your answer should be very brief. -6.21e+11. In the year 1998, what is the difference between the Exports in Georgia and Exports in Guatemala?
Your answer should be compact. -3.90e+1. In the year 1998, what is the difference between the Exports in Georgia and Exports in Guinea?
Your answer should be very brief. -1.64e+12. In the year 1998, what is the difference between the Exports of Georgia and Exports of Mexico?
Ensure brevity in your answer.  -2.29e+12. In the year 1998, what is the difference between the Exports in Guatemala and Exports in Guinea?
Your response must be concise. -1.60e+12. In the year 1998, what is the difference between the Exports of Guatemala and Exports of Mexico?
Give a very brief answer. -2.25e+12. In the year 1998, what is the difference between the Exports in Guinea and Exports in Mexico?
Provide a succinct answer. -6.47e+11. In the year 1999, what is the difference between the Exports in Georgia and Exports in Guatemala?
Your answer should be compact. -4.07e+1. In the year 1999, what is the difference between the Exports of Georgia and Exports of Guinea?
Keep it short and to the point. -1.76e+12. In the year 1999, what is the difference between the Exports in Georgia and Exports in Mexico?
Offer a terse response. -2.44e+12. In the year 1999, what is the difference between the Exports of Guatemala and Exports of Guinea?
Keep it short and to the point. -1.72e+12. In the year 1999, what is the difference between the Exports in Guatemala and Exports in Mexico?
Provide a short and direct response. -2.40e+12. In the year 1999, what is the difference between the Exports of Guinea and Exports of Mexico?
Ensure brevity in your answer.  -6.79e+11. In the year 2000, what is the difference between the Exports of Georgia and Exports of Guatemala?
Your response must be concise. -4.21e+1. In the year 2000, what is the difference between the Exports in Georgia and Exports in Guinea?
Your answer should be compact. -1.74e+12. In the year 2000, what is the difference between the Exports in Georgia and Exports in Mexico?
Provide a short and direct response. -2.71e+12. In the year 2000, what is the difference between the Exports in Guatemala and Exports in Guinea?
Offer a very short reply. -1.70e+12. In the year 2000, what is the difference between the Exports of Guatemala and Exports of Mexico?
Ensure brevity in your answer.  -2.66e+12. In the year 2000, what is the difference between the Exports of Guinea and Exports of Mexico?
Provide a short and direct response. -9.68e+11. In the year 2001, what is the difference between the Exports of Georgia and Exports of Guatemala?
Provide a short and direct response. -4.03e+1. In the year 2001, what is the difference between the Exports in Georgia and Exports in Guinea?
Provide a short and direct response. -1.87e+12. In the year 2001, what is the difference between the Exports of Georgia and Exports of Mexico?
Your answer should be compact. -2.61e+12. In the year 2001, what is the difference between the Exports in Guatemala and Exports in Guinea?
Your answer should be compact. -1.83e+12. In the year 2001, what is the difference between the Exports in Guatemala and Exports in Mexico?
Provide a succinct answer. -2.57e+12. In the year 2001, what is the difference between the Exports in Guinea and Exports in Mexico?
Offer a very short reply. -7.42e+11. In the year 2002, what is the difference between the Exports of Georgia and Exports of Guatemala?
Ensure brevity in your answer.  -4.03e+1. In the year 2002, what is the difference between the Exports in Georgia and Exports in Guinea?
Your response must be concise. -1.84e+12. In the year 2002, what is the difference between the Exports in Georgia and Exports in Mexico?
Your response must be concise. -2.67e+12. In the year 2002, what is the difference between the Exports of Guatemala and Exports of Guinea?
Offer a very short reply. -1.80e+12. In the year 2002, what is the difference between the Exports of Guatemala and Exports of Mexico?
Offer a very short reply. -2.63e+12. In the year 2002, what is the difference between the Exports in Guinea and Exports in Mexico?
Provide a succinct answer. -8.23e+11. What is the ratio of the Exports of Georgia in 1995 to that in 1996?
Provide a succinct answer. 0.92. What is the ratio of the Exports of Guatemala in 1995 to that in 1996?
Give a very brief answer. 0.92. What is the ratio of the Exports of Guinea in 1995 to that in 1996?
Offer a very short reply. 1.08. What is the ratio of the Exports in Mexico in 1995 to that in 1996?
Your answer should be very brief. 0.85. What is the ratio of the Exports in Georgia in 1995 to that in 1997?
Provide a short and direct response. 0.71. What is the ratio of the Exports of Guatemala in 1995 to that in 1997?
Ensure brevity in your answer.  0.85. What is the ratio of the Exports in Guinea in 1995 to that in 1997?
Offer a terse response. 1.16. What is the ratio of the Exports of Mexico in 1995 to that in 1997?
Your answer should be compact. 0.78. What is the ratio of the Exports in Georgia in 1995 to that in 1998?
Your answer should be compact. 0.65. What is the ratio of the Exports of Guatemala in 1995 to that in 1998?
Give a very brief answer. 0.83. What is the ratio of the Exports in Guinea in 1995 to that in 1998?
Provide a short and direct response. 1.07. What is the ratio of the Exports in Mexico in 1995 to that in 1998?
Offer a very short reply. 0.72. What is the ratio of the Exports of Georgia in 1995 to that in 1999?
Make the answer very short. 0.55. What is the ratio of the Exports of Guatemala in 1995 to that in 1999?
Ensure brevity in your answer.  0.79. What is the ratio of the Exports in Mexico in 1995 to that in 1999?
Offer a terse response. 0.68. What is the ratio of the Exports of Georgia in 1995 to that in 2000?
Offer a terse response. 0.45. What is the ratio of the Exports in Guatemala in 1995 to that in 2000?
Offer a very short reply. 0.77. What is the ratio of the Exports of Mexico in 1995 to that in 2000?
Ensure brevity in your answer.  0.61. What is the ratio of the Exports in Georgia in 1995 to that in 2001?
Provide a succinct answer. 0.4. What is the ratio of the Exports of Guatemala in 1995 to that in 2001?
Offer a very short reply. 0.8. What is the ratio of the Exports of Guinea in 1995 to that in 2001?
Your answer should be very brief. 0.93. What is the ratio of the Exports of Mexico in 1995 to that in 2001?
Your answer should be compact. 0.63. What is the ratio of the Exports of Georgia in 1995 to that in 2002?
Keep it short and to the point. 0.32. What is the ratio of the Exports of Guatemala in 1995 to that in 2002?
Keep it short and to the point. 0.79. What is the ratio of the Exports of Guinea in 1995 to that in 2002?
Give a very brief answer. 0.95. What is the ratio of the Exports of Mexico in 1995 to that in 2002?
Keep it short and to the point. 0.62. What is the ratio of the Exports of Georgia in 1996 to that in 1997?
Offer a very short reply. 0.77. What is the ratio of the Exports in Guatemala in 1996 to that in 1997?
Your response must be concise. 0.93. What is the ratio of the Exports in Guinea in 1996 to that in 1997?
Keep it short and to the point. 1.08. What is the ratio of the Exports in Mexico in 1996 to that in 1997?
Keep it short and to the point. 0.92. What is the ratio of the Exports in Georgia in 1996 to that in 1998?
Make the answer very short. 0.71. What is the ratio of the Exports in Guatemala in 1996 to that in 1998?
Make the answer very short. 0.9. What is the ratio of the Exports of Guinea in 1996 to that in 1998?
Offer a terse response. 0.99. What is the ratio of the Exports of Mexico in 1996 to that in 1998?
Your answer should be very brief. 0.86. What is the ratio of the Exports in Georgia in 1996 to that in 1999?
Offer a very short reply. 0.6. What is the ratio of the Exports in Guatemala in 1996 to that in 1999?
Your response must be concise. 0.86. What is the ratio of the Exports in Guinea in 1996 to that in 1999?
Keep it short and to the point. 0.92. What is the ratio of the Exports of Mexico in 1996 to that in 1999?
Provide a short and direct response. 0.8. What is the ratio of the Exports in Georgia in 1996 to that in 2000?
Keep it short and to the point. 0.49. What is the ratio of the Exports in Guatemala in 1996 to that in 2000?
Your answer should be very brief. 0.83. What is the ratio of the Exports in Guinea in 1996 to that in 2000?
Make the answer very short. 0.94. What is the ratio of the Exports of Mexico in 1996 to that in 2000?
Give a very brief answer. 0.72. What is the ratio of the Exports in Georgia in 1996 to that in 2001?
Give a very brief answer. 0.44. What is the ratio of the Exports in Guatemala in 1996 to that in 2001?
Provide a short and direct response. 0.87. What is the ratio of the Exports in Guinea in 1996 to that in 2001?
Offer a terse response. 0.87. What is the ratio of the Exports in Mexico in 1996 to that in 2001?
Offer a very short reply. 0.75. What is the ratio of the Exports in Georgia in 1996 to that in 2002?
Your answer should be compact. 0.35. What is the ratio of the Exports in Guatemala in 1996 to that in 2002?
Offer a terse response. 0.86. What is the ratio of the Exports of Guinea in 1996 to that in 2002?
Offer a terse response. 0.88. What is the ratio of the Exports in Mexico in 1996 to that in 2002?
Ensure brevity in your answer.  0.73. What is the ratio of the Exports in Georgia in 1997 to that in 1998?
Your answer should be compact. 0.92. What is the ratio of the Exports of Guatemala in 1997 to that in 1998?
Your answer should be very brief. 0.98. What is the ratio of the Exports of Guinea in 1997 to that in 1998?
Provide a short and direct response. 0.92. What is the ratio of the Exports in Mexico in 1997 to that in 1998?
Your answer should be very brief. 0.93. What is the ratio of the Exports of Georgia in 1997 to that in 1999?
Offer a very short reply. 0.77. What is the ratio of the Exports of Guatemala in 1997 to that in 1999?
Make the answer very short. 0.93. What is the ratio of the Exports in Guinea in 1997 to that in 1999?
Your response must be concise. 0.86. What is the ratio of the Exports of Mexico in 1997 to that in 1999?
Your answer should be compact. 0.87. What is the ratio of the Exports of Georgia in 1997 to that in 2000?
Your answer should be very brief. 0.63. What is the ratio of the Exports of Guatemala in 1997 to that in 2000?
Offer a very short reply. 0.9. What is the ratio of the Exports in Guinea in 1997 to that in 2000?
Offer a terse response. 0.87. What is the ratio of the Exports of Mexico in 1997 to that in 2000?
Your answer should be very brief. 0.79. What is the ratio of the Exports in Georgia in 1997 to that in 2001?
Offer a terse response. 0.56. What is the ratio of the Exports in Guatemala in 1997 to that in 2001?
Offer a very short reply. 0.94. What is the ratio of the Exports in Guinea in 1997 to that in 2001?
Keep it short and to the point. 0.81. What is the ratio of the Exports in Mexico in 1997 to that in 2001?
Your answer should be very brief. 0.81. What is the ratio of the Exports of Georgia in 1997 to that in 2002?
Offer a terse response. 0.45. What is the ratio of the Exports of Guatemala in 1997 to that in 2002?
Offer a terse response. 0.93. What is the ratio of the Exports of Guinea in 1997 to that in 2002?
Your response must be concise. 0.82. What is the ratio of the Exports in Mexico in 1997 to that in 2002?
Your response must be concise. 0.8. What is the ratio of the Exports of Georgia in 1998 to that in 1999?
Keep it short and to the point. 0.84. What is the ratio of the Exports in Guatemala in 1998 to that in 1999?
Provide a succinct answer. 0.96. What is the ratio of the Exports in Guinea in 1998 to that in 1999?
Ensure brevity in your answer.  0.93. What is the ratio of the Exports in Mexico in 1998 to that in 1999?
Offer a terse response. 0.94. What is the ratio of the Exports in Georgia in 1998 to that in 2000?
Offer a very short reply. 0.68. What is the ratio of the Exports in Guatemala in 1998 to that in 2000?
Give a very brief answer. 0.92. What is the ratio of the Exports in Guinea in 1998 to that in 2000?
Keep it short and to the point. 0.94. What is the ratio of the Exports of Mexico in 1998 to that in 2000?
Keep it short and to the point. 0.85. What is the ratio of the Exports in Georgia in 1998 to that in 2001?
Your answer should be compact. 0.61. What is the ratio of the Exports in Guatemala in 1998 to that in 2001?
Ensure brevity in your answer.  0.96. What is the ratio of the Exports of Guinea in 1998 to that in 2001?
Give a very brief answer. 0.88. What is the ratio of the Exports in Mexico in 1998 to that in 2001?
Provide a short and direct response. 0.88. What is the ratio of the Exports in Georgia in 1998 to that in 2002?
Offer a very short reply. 0.49. What is the ratio of the Exports in Guatemala in 1998 to that in 2002?
Ensure brevity in your answer.  0.95. What is the ratio of the Exports of Guinea in 1998 to that in 2002?
Make the answer very short. 0.89. What is the ratio of the Exports in Mexico in 1998 to that in 2002?
Your answer should be very brief. 0.86. What is the ratio of the Exports of Georgia in 1999 to that in 2000?
Provide a succinct answer. 0.81. What is the ratio of the Exports in Guatemala in 1999 to that in 2000?
Your answer should be very brief. 0.96. What is the ratio of the Exports of Guinea in 1999 to that in 2000?
Make the answer very short. 1.01. What is the ratio of the Exports of Mexico in 1999 to that in 2000?
Your response must be concise. 0.9. What is the ratio of the Exports of Georgia in 1999 to that in 2001?
Your answer should be compact. 0.73. What is the ratio of the Exports of Guinea in 1999 to that in 2001?
Give a very brief answer. 0.94. What is the ratio of the Exports in Mexico in 1999 to that in 2001?
Keep it short and to the point. 0.93. What is the ratio of the Exports of Georgia in 1999 to that in 2002?
Ensure brevity in your answer.  0.58. What is the ratio of the Exports in Guatemala in 1999 to that in 2002?
Your response must be concise. 1. What is the ratio of the Exports in Guinea in 1999 to that in 2002?
Offer a very short reply. 0.95. What is the ratio of the Exports of Mexico in 1999 to that in 2002?
Your response must be concise. 0.91. What is the ratio of the Exports of Georgia in 2000 to that in 2001?
Offer a very short reply. 0.9. What is the ratio of the Exports of Guatemala in 2000 to that in 2001?
Your response must be concise. 1.04. What is the ratio of the Exports in Guinea in 2000 to that in 2001?
Offer a very short reply. 0.93. What is the ratio of the Exports of Mexico in 2000 to that in 2001?
Provide a short and direct response. 1.04. What is the ratio of the Exports of Georgia in 2000 to that in 2002?
Offer a terse response. 0.71. What is the ratio of the Exports of Guatemala in 2000 to that in 2002?
Your answer should be compact. 1.03. What is the ratio of the Exports of Guinea in 2000 to that in 2002?
Provide a succinct answer. 0.94. What is the ratio of the Exports in Mexico in 2000 to that in 2002?
Keep it short and to the point. 1.01. What is the ratio of the Exports in Georgia in 2001 to that in 2002?
Give a very brief answer. 0.79. What is the ratio of the Exports in Guatemala in 2001 to that in 2002?
Your answer should be very brief. 0.99. What is the ratio of the Exports in Guinea in 2001 to that in 2002?
Your response must be concise. 1.01. What is the ratio of the Exports in Mexico in 2001 to that in 2002?
Keep it short and to the point. 0.98. What is the difference between the highest and the second highest Exports of Georgia?
Give a very brief answer. 3.08e+08. What is the difference between the highest and the second highest Exports in Guatemala?
Offer a very short reply. 1.43e+09. What is the difference between the highest and the second highest Exports in Guinea?
Offer a terse response. 2.67e+1. What is the difference between the highest and the second highest Exports in Mexico?
Offer a terse response. 3.81e+1. What is the difference between the highest and the lowest Exports of Georgia?
Provide a succinct answer. 1.02e+09. What is the difference between the highest and the lowest Exports of Guatemala?
Give a very brief answer. 1.01e+1. What is the difference between the highest and the lowest Exports in Guinea?
Offer a terse response. 3.65e+11. What is the difference between the highest and the lowest Exports in Mexico?
Provide a short and direct response. 1.05e+12. 